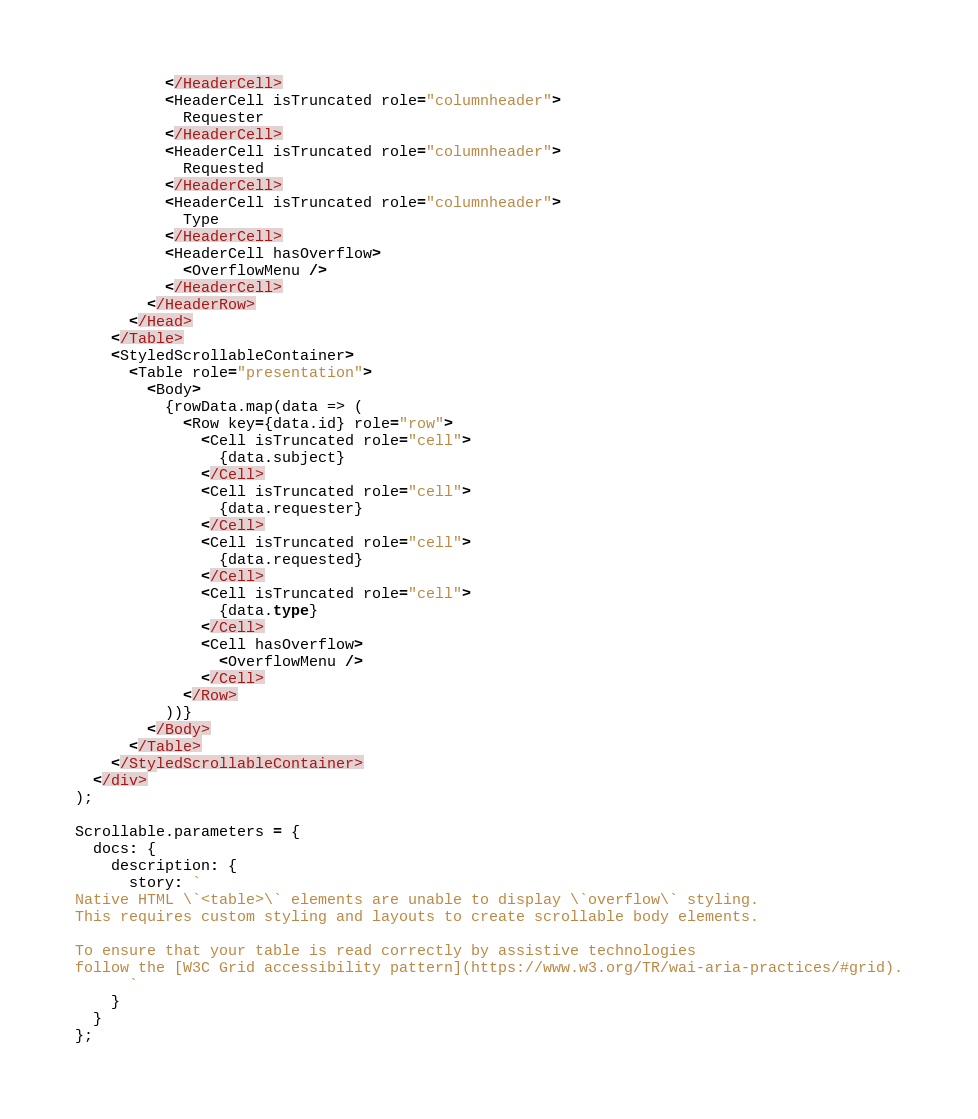Convert code to text. <code><loc_0><loc_0><loc_500><loc_500><_TypeScript_>          </HeaderCell>
          <HeaderCell isTruncated role="columnheader">
            Requester
          </HeaderCell>
          <HeaderCell isTruncated role="columnheader">
            Requested
          </HeaderCell>
          <HeaderCell isTruncated role="columnheader">
            Type
          </HeaderCell>
          <HeaderCell hasOverflow>
            <OverflowMenu />
          </HeaderCell>
        </HeaderRow>
      </Head>
    </Table>
    <StyledScrollableContainer>
      <Table role="presentation">
        <Body>
          {rowData.map(data => (
            <Row key={data.id} role="row">
              <Cell isTruncated role="cell">
                {data.subject}
              </Cell>
              <Cell isTruncated role="cell">
                {data.requester}
              </Cell>
              <Cell isTruncated role="cell">
                {data.requested}
              </Cell>
              <Cell isTruncated role="cell">
                {data.type}
              </Cell>
              <Cell hasOverflow>
                <OverflowMenu />
              </Cell>
            </Row>
          ))}
        </Body>
      </Table>
    </StyledScrollableContainer>
  </div>
);

Scrollable.parameters = {
  docs: {
    description: {
      story: `
Native HTML \`<table>\` elements are unable to display \`overflow\` styling.
This requires custom styling and layouts to create scrollable body elements.

To ensure that your table is read correctly by assistive technologies
follow the [W3C Grid accessibility pattern](https://www.w3.org/TR/wai-aria-practices/#grid).
      `
    }
  }
};
</code> 